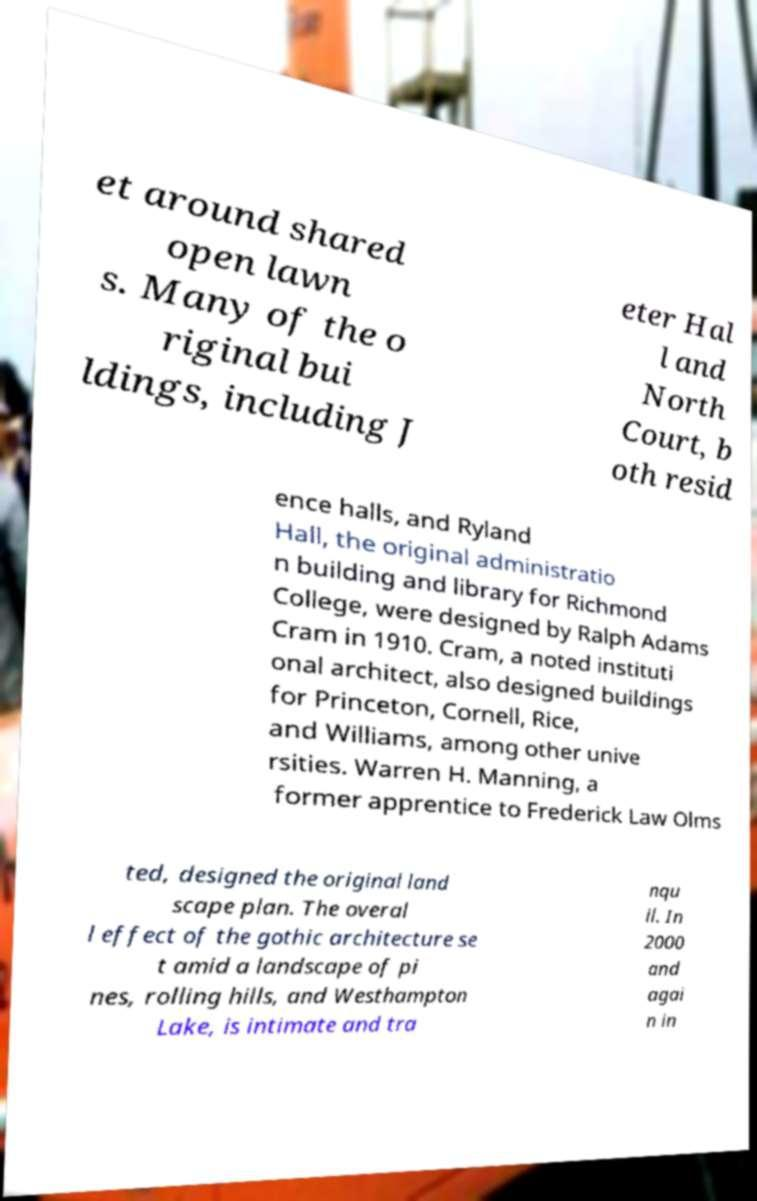Please read and relay the text visible in this image. What does it say? et around shared open lawn s. Many of the o riginal bui ldings, including J eter Hal l and North Court, b oth resid ence halls, and Ryland Hall, the original administratio n building and library for Richmond College, were designed by Ralph Adams Cram in 1910. Cram, a noted instituti onal architect, also designed buildings for Princeton, Cornell, Rice, and Williams, among other unive rsities. Warren H. Manning, a former apprentice to Frederick Law Olms ted, designed the original land scape plan. The overal l effect of the gothic architecture se t amid a landscape of pi nes, rolling hills, and Westhampton Lake, is intimate and tra nqu il. In 2000 and agai n in 